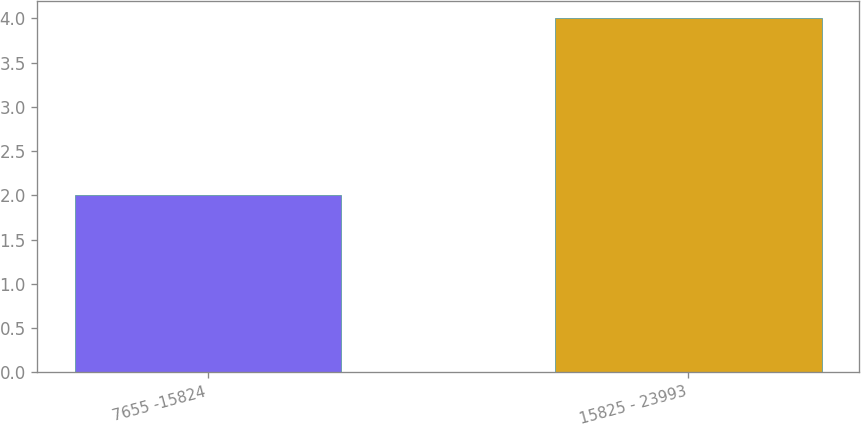<chart> <loc_0><loc_0><loc_500><loc_500><bar_chart><fcel>7655 -15824<fcel>15825 - 23993<nl><fcel>2<fcel>4<nl></chart> 